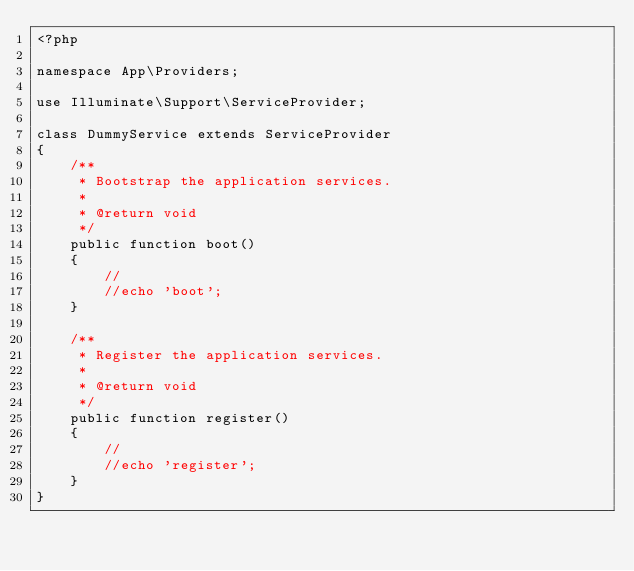Convert code to text. <code><loc_0><loc_0><loc_500><loc_500><_PHP_><?php

namespace App\Providers;

use Illuminate\Support\ServiceProvider;

class DummyService extends ServiceProvider
{
    /**
     * Bootstrap the application services.
     *
     * @return void
     */
    public function boot()
    {
        //
        //echo 'boot';
    }

    /**
     * Register the application services.
     *
     * @return void
     */
    public function register()
    {
        //
        //echo 'register';
    }
}
</code> 